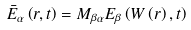<formula> <loc_0><loc_0><loc_500><loc_500>\bar { E } _ { \alpha } \left ( r , t \right ) = M _ { \beta \alpha } E _ { \beta } \left ( W \left ( r \right ) , t \right )</formula> 